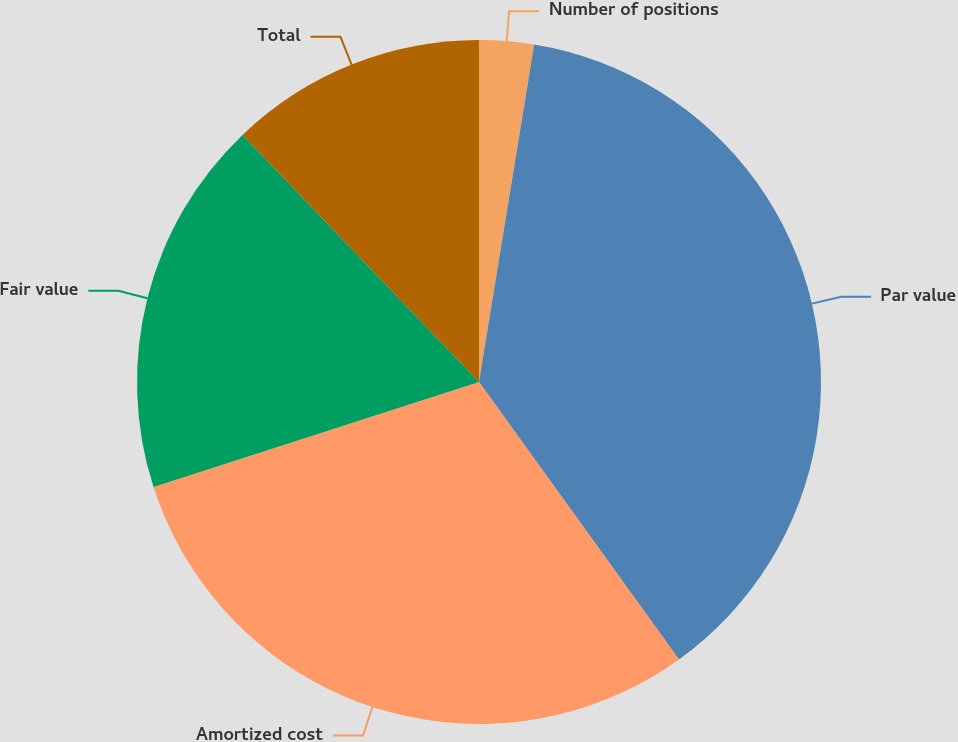<chart> <loc_0><loc_0><loc_500><loc_500><pie_chart><fcel>Number of positions<fcel>Par value<fcel>Amortized cost<fcel>Fair value<fcel>Total<nl><fcel>2.58%<fcel>37.48%<fcel>29.97%<fcel>17.82%<fcel>12.15%<nl></chart> 